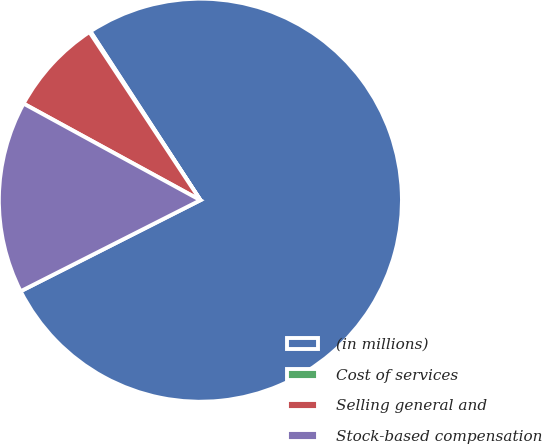Convert chart. <chart><loc_0><loc_0><loc_500><loc_500><pie_chart><fcel>(in millions)<fcel>Cost of services<fcel>Selling general and<fcel>Stock-based compensation<nl><fcel>76.73%<fcel>0.09%<fcel>7.76%<fcel>15.42%<nl></chart> 